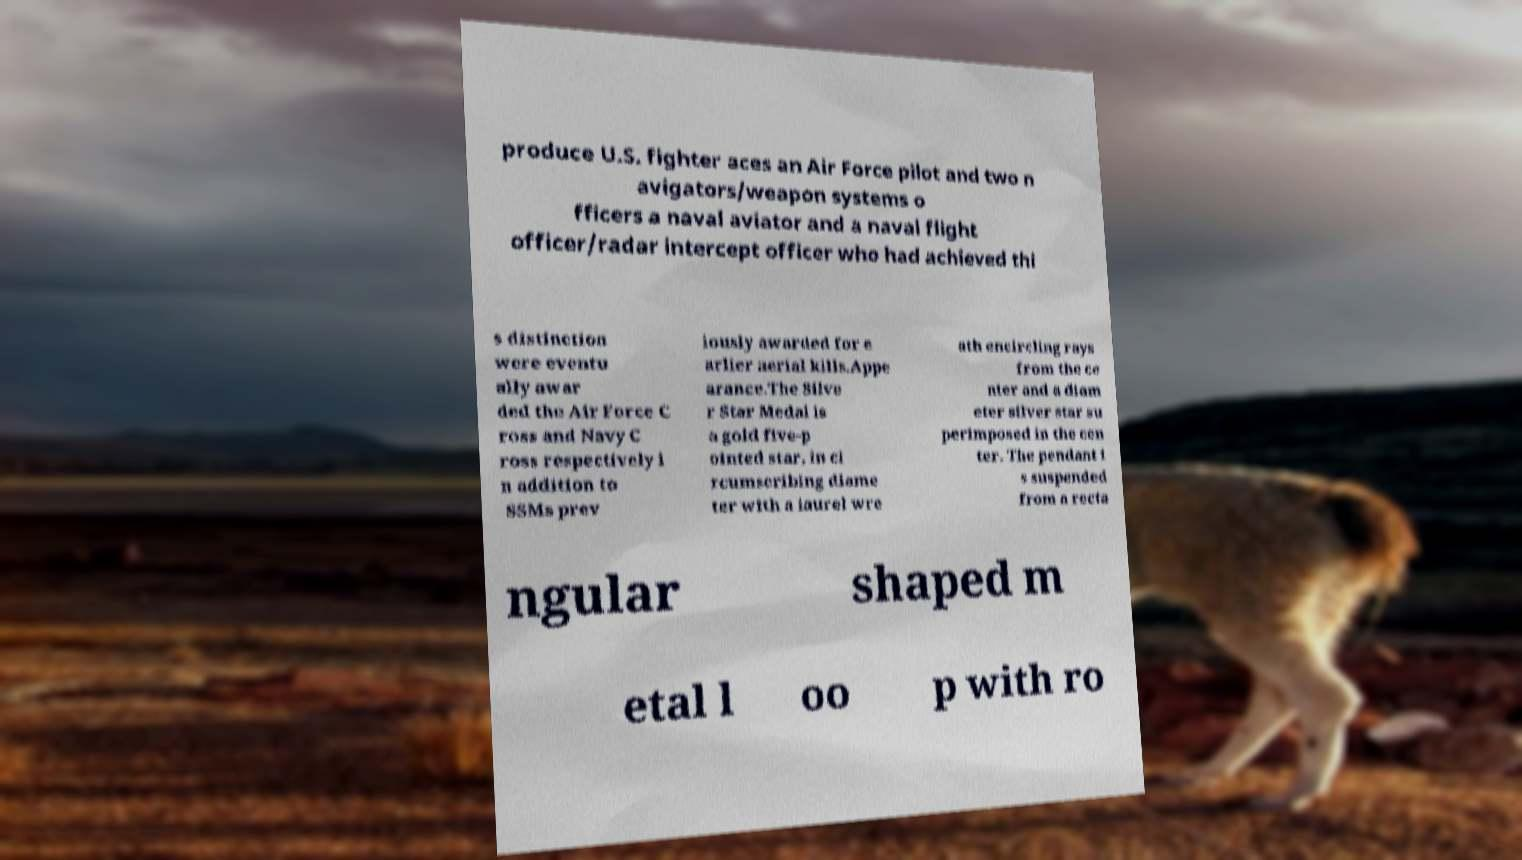Please identify and transcribe the text found in this image. produce U.S. fighter aces an Air Force pilot and two n avigators/weapon systems o fficers a naval aviator and a naval flight officer/radar intercept officer who had achieved thi s distinction were eventu ally awar ded the Air Force C ross and Navy C ross respectively i n addition to SSMs prev iously awarded for e arlier aerial kills.Appe arance.The Silve r Star Medal is a gold five-p ointed star, in ci rcumscribing diame ter with a laurel wre ath encircling rays from the ce nter and a diam eter silver star su perimposed in the cen ter. The pendant i s suspended from a recta ngular shaped m etal l oo p with ro 